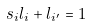<formula> <loc_0><loc_0><loc_500><loc_500>s _ { i } l _ { i } + l _ { i ^ { \prime } } = 1</formula> 